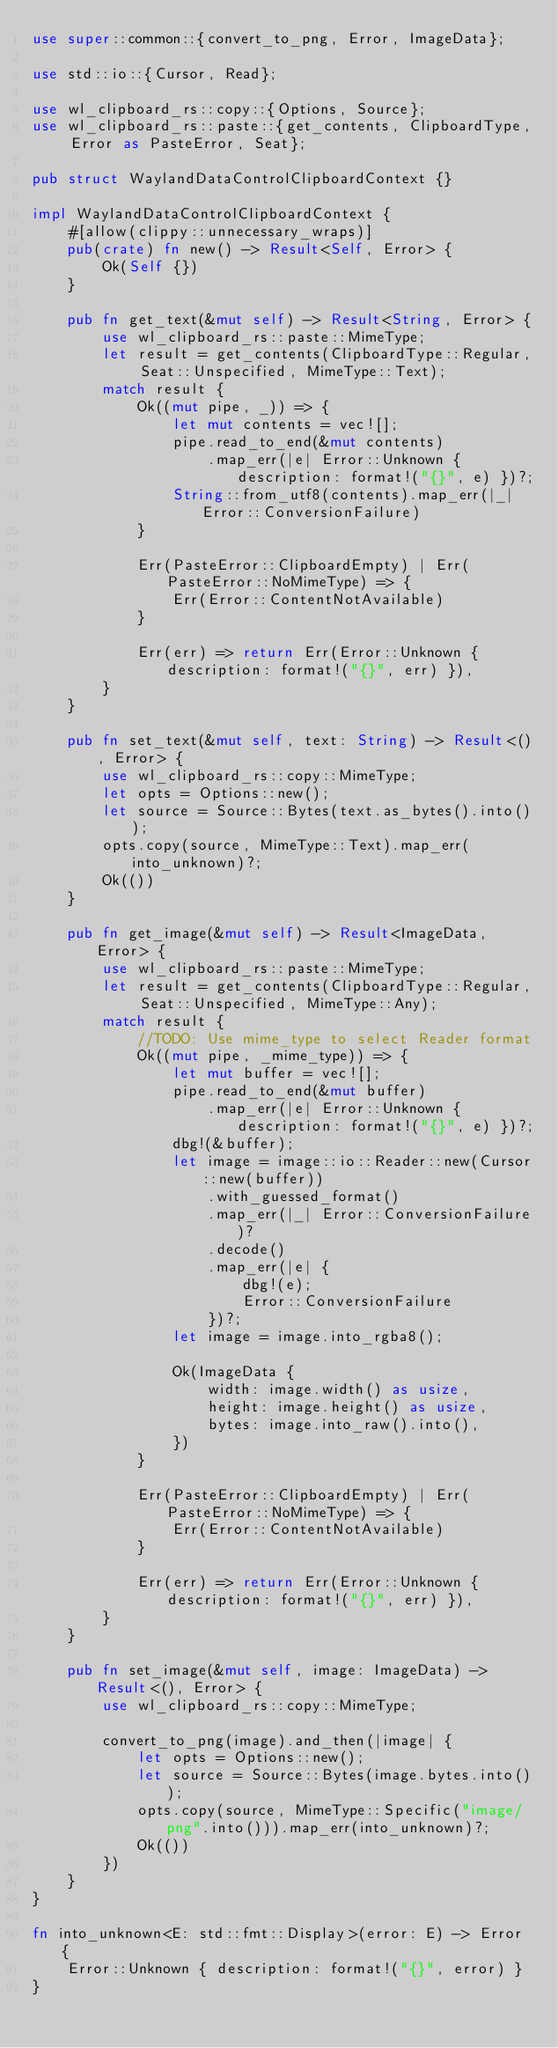Convert code to text. <code><loc_0><loc_0><loc_500><loc_500><_Rust_>use super::common::{convert_to_png, Error, ImageData};

use std::io::{Cursor, Read};

use wl_clipboard_rs::copy::{Options, Source};
use wl_clipboard_rs::paste::{get_contents, ClipboardType, Error as PasteError, Seat};

pub struct WaylandDataControlClipboardContext {}

impl WaylandDataControlClipboardContext {
	#[allow(clippy::unnecessary_wraps)]
	pub(crate) fn new() -> Result<Self, Error> {
		Ok(Self {})
	}

	pub fn get_text(&mut self) -> Result<String, Error> {
		use wl_clipboard_rs::paste::MimeType;
		let result = get_contents(ClipboardType::Regular, Seat::Unspecified, MimeType::Text);
		match result {
			Ok((mut pipe, _)) => {
				let mut contents = vec![];
				pipe.read_to_end(&mut contents)
					.map_err(|e| Error::Unknown { description: format!("{}", e) })?;
				String::from_utf8(contents).map_err(|_| Error::ConversionFailure)
			}

			Err(PasteError::ClipboardEmpty) | Err(PasteError::NoMimeType) => {
				Err(Error::ContentNotAvailable)
			}

			Err(err) => return Err(Error::Unknown { description: format!("{}", err) }),
		}
	}

	pub fn set_text(&mut self, text: String) -> Result<(), Error> {
		use wl_clipboard_rs::copy::MimeType;
		let opts = Options::new();
		let source = Source::Bytes(text.as_bytes().into());
		opts.copy(source, MimeType::Text).map_err(into_unknown)?;
		Ok(())
	}

	pub fn get_image(&mut self) -> Result<ImageData, Error> {
		use wl_clipboard_rs::paste::MimeType;
		let result = get_contents(ClipboardType::Regular, Seat::Unspecified, MimeType::Any);
		match result {
			//TODO: Use mime_type to select Reader format
			Ok((mut pipe, _mime_type)) => {
				let mut buffer = vec![];
				pipe.read_to_end(&mut buffer)
					.map_err(|e| Error::Unknown { description: format!("{}", e) })?;
				dbg!(&buffer);
				let image = image::io::Reader::new(Cursor::new(buffer))
					.with_guessed_format()
					.map_err(|_| Error::ConversionFailure)?
					.decode()
					.map_err(|e| {
						dbg!(e);
						Error::ConversionFailure
					})?;
				let image = image.into_rgba8();

				Ok(ImageData {
					width: image.width() as usize,
					height: image.height() as usize,
					bytes: image.into_raw().into(),
				})
			}

			Err(PasteError::ClipboardEmpty) | Err(PasteError::NoMimeType) => {
				Err(Error::ContentNotAvailable)
			}

			Err(err) => return Err(Error::Unknown { description: format!("{}", err) }),
		}
	}

	pub fn set_image(&mut self, image: ImageData) -> Result<(), Error> {
		use wl_clipboard_rs::copy::MimeType;

		convert_to_png(image).and_then(|image| {
			let opts = Options::new();
			let source = Source::Bytes(image.bytes.into());
			opts.copy(source, MimeType::Specific("image/png".into())).map_err(into_unknown)?;
			Ok(())
		})
	}
}

fn into_unknown<E: std::fmt::Display>(error: E) -> Error {
	Error::Unknown { description: format!("{}", error) }
}
</code> 